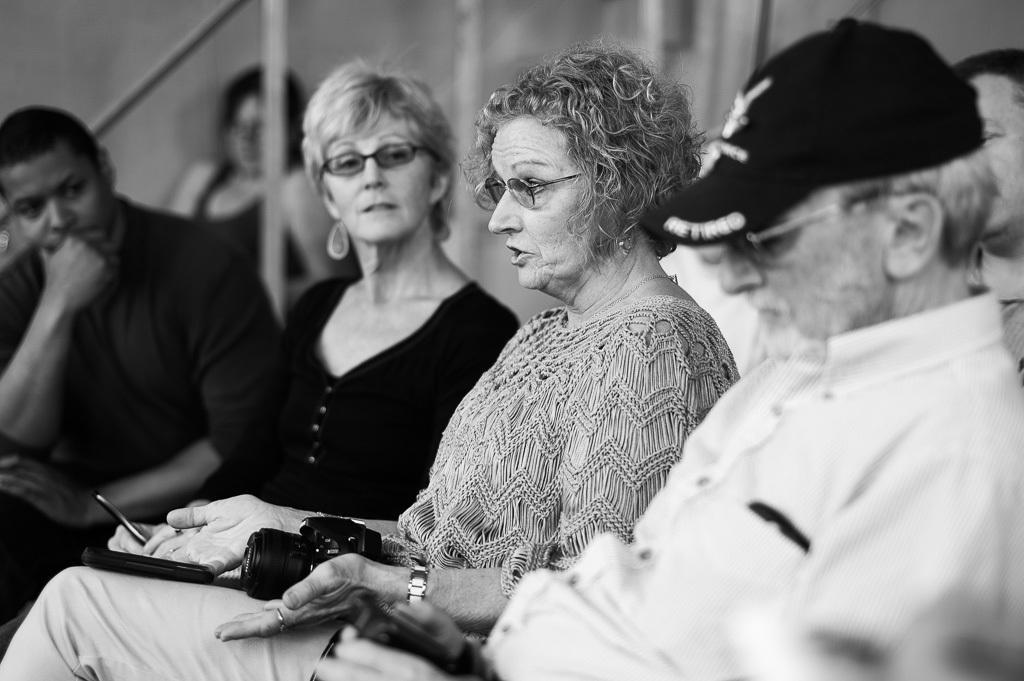Could you give a brief overview of what you see in this image? In this image I can see few people are sitting. Here I can see two of them are wearing specs and one is wearing a cap. I can also see camera over here and I can see this image is black and white in colour. 